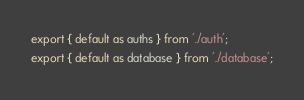<code> <loc_0><loc_0><loc_500><loc_500><_JavaScript_>export { default as auths } from './auth';
export { default as database } from './database';
</code> 